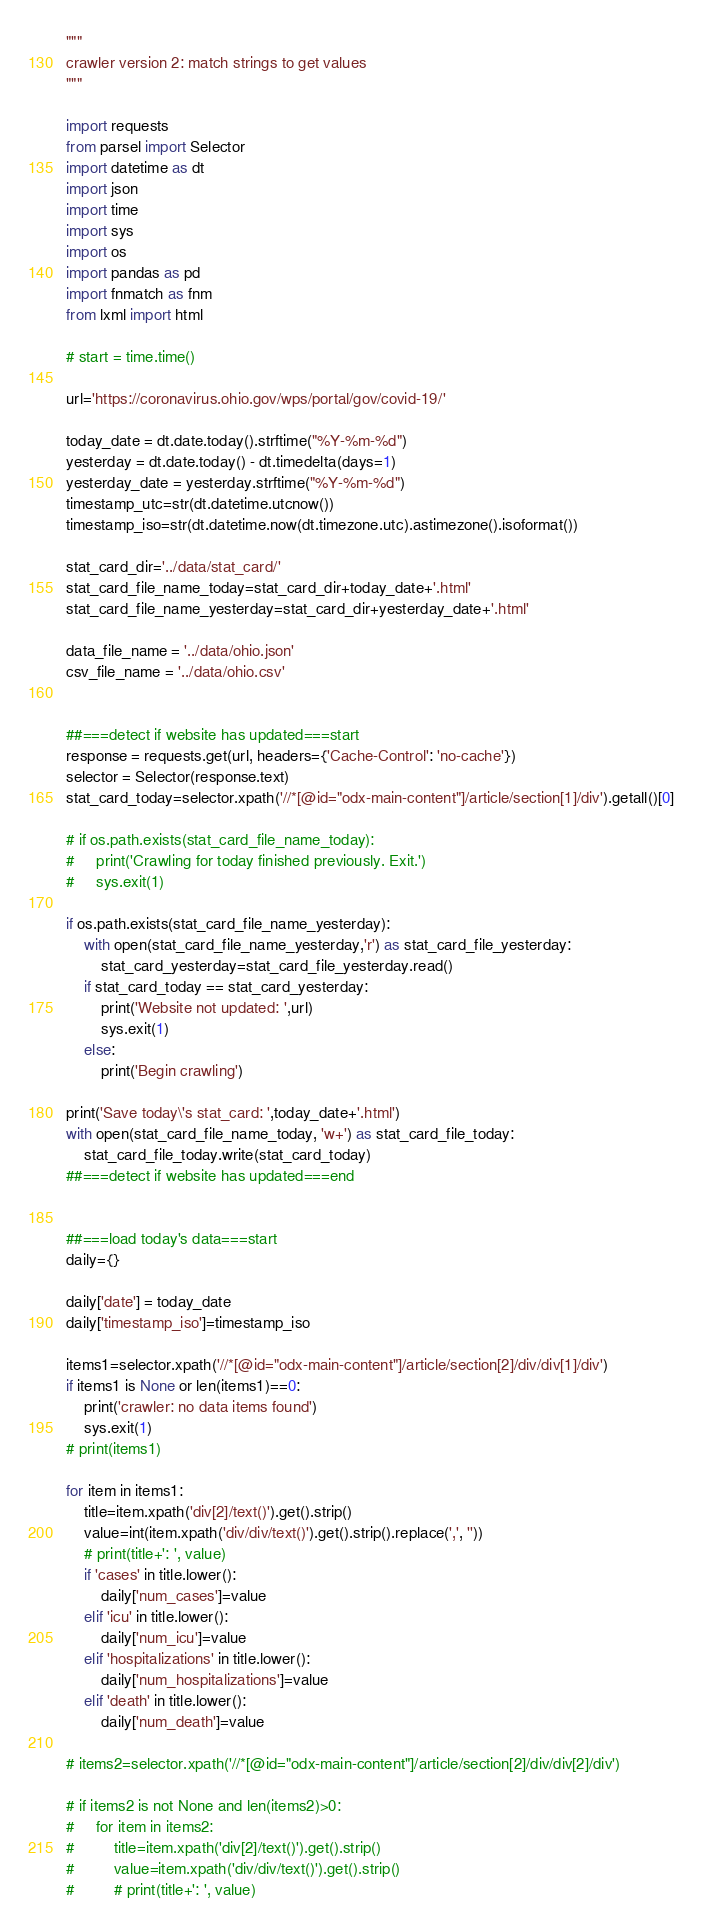Convert code to text. <code><loc_0><loc_0><loc_500><loc_500><_Python_>"""
crawler version 2: match strings to get values
"""

import requests
from parsel import Selector
import datetime as dt
import json
import time
import sys
import os
import pandas as pd
import fnmatch as fnm
from lxml import html

# start = time.time()

url='https://coronavirus.ohio.gov/wps/portal/gov/covid-19/'

today_date = dt.date.today().strftime("%Y-%m-%d")
yesterday = dt.date.today() - dt.timedelta(days=1)
yesterday_date = yesterday.strftime("%Y-%m-%d")
timestamp_utc=str(dt.datetime.utcnow())
timestamp_iso=str(dt.datetime.now(dt.timezone.utc).astimezone().isoformat())

stat_card_dir='../data/stat_card/'
stat_card_file_name_today=stat_card_dir+today_date+'.html'
stat_card_file_name_yesterday=stat_card_dir+yesterday_date+'.html'

data_file_name = '../data/ohio.json'
csv_file_name = '../data/ohio.csv'


##===detect if website has updated===start
response = requests.get(url, headers={'Cache-Control': 'no-cache'})
selector = Selector(response.text)
stat_card_today=selector.xpath('//*[@id="odx-main-content"]/article/section[1]/div').getall()[0]

# if os.path.exists(stat_card_file_name_today):
#     print('Crawling for today finished previously. Exit.')
#     sys.exit(1)

if os.path.exists(stat_card_file_name_yesterday):
    with open(stat_card_file_name_yesterday,'r') as stat_card_file_yesterday:
        stat_card_yesterday=stat_card_file_yesterday.read()
    if stat_card_today == stat_card_yesterday:
        print('Website not updated: ',url)
        sys.exit(1)
    else:
        print('Begin crawling')

print('Save today\'s stat_card: ',today_date+'.html')
with open(stat_card_file_name_today, 'w+') as stat_card_file_today:
    stat_card_file_today.write(stat_card_today)
##===detect if website has updated===end


##===load today's data===start
daily={}

daily['date'] = today_date
daily['timestamp_iso']=timestamp_iso

items1=selector.xpath('//*[@id="odx-main-content"]/article/section[2]/div/div[1]/div')
if items1 is None or len(items1)==0:
    print('crawler: no data items found')
    sys.exit(1)
# print(items1)

for item in items1:
    title=item.xpath('div[2]/text()').get().strip()
    value=int(item.xpath('div/div/text()').get().strip().replace(',', ''))
    # print(title+': ', value)
    if 'cases' in title.lower():
        daily['num_cases']=value
    elif 'icu' in title.lower():
        daily['num_icu']=value
    elif 'hospitalizations' in title.lower():
        daily['num_hospitalizations']=value
    elif 'death' in title.lower():
        daily['num_death']=value

# items2=selector.xpath('//*[@id="odx-main-content"]/article/section[2]/div/div[2]/div')

# if items2 is not None and len(items2)>0:
#     for item in items2:
#         title=item.xpath('div[2]/text()').get().strip()
#         value=item.xpath('div/div/text()').get().strip()
#         # print(title+': ', value)</code> 